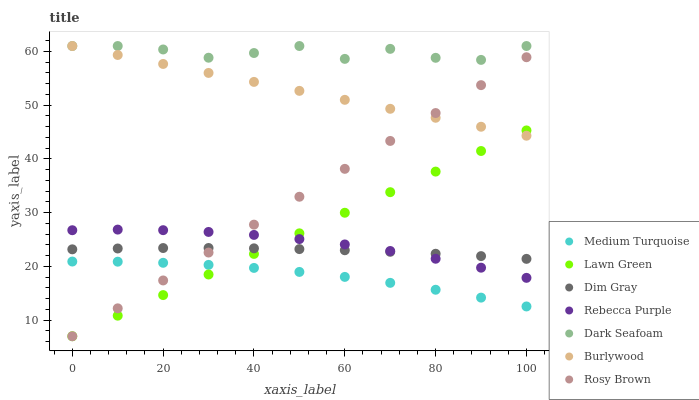Does Medium Turquoise have the minimum area under the curve?
Answer yes or no. Yes. Does Dark Seafoam have the maximum area under the curve?
Answer yes or no. Yes. Does Dim Gray have the minimum area under the curve?
Answer yes or no. No. Does Dim Gray have the maximum area under the curve?
Answer yes or no. No. Is Lawn Green the smoothest?
Answer yes or no. Yes. Is Dark Seafoam the roughest?
Answer yes or no. Yes. Is Dim Gray the smoothest?
Answer yes or no. No. Is Dim Gray the roughest?
Answer yes or no. No. Does Lawn Green have the lowest value?
Answer yes or no. Yes. Does Dim Gray have the lowest value?
Answer yes or no. No. Does Dark Seafoam have the highest value?
Answer yes or no. Yes. Does Dim Gray have the highest value?
Answer yes or no. No. Is Lawn Green less than Dark Seafoam?
Answer yes or no. Yes. Is Burlywood greater than Rebecca Purple?
Answer yes or no. Yes. Does Rosy Brown intersect Lawn Green?
Answer yes or no. Yes. Is Rosy Brown less than Lawn Green?
Answer yes or no. No. Is Rosy Brown greater than Lawn Green?
Answer yes or no. No. Does Lawn Green intersect Dark Seafoam?
Answer yes or no. No. 